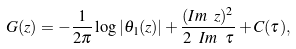<formula> <loc_0><loc_0><loc_500><loc_500>G ( z ) = - \frac { 1 } { 2 \pi } \log | \theta _ { 1 } ( z ) | + \frac { ( I m \ z ) ^ { 2 } } { 2 \ I m \ \tau } + C ( \tau ) ,</formula> 